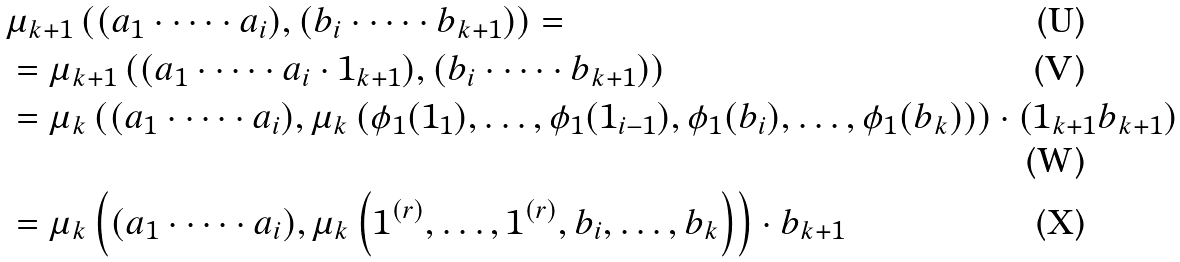<formula> <loc_0><loc_0><loc_500><loc_500>& \mu _ { k + 1 } \left ( ( a _ { 1 } \cdot \dots \cdot a _ { i } ) , ( b _ { i } \cdot \dots \cdot b _ { k + 1 } ) \right ) = \\ & = \mu _ { k + 1 } \left ( ( a _ { 1 } \cdot \dots \cdot a _ { i } \cdot 1 _ { k + 1 } ) , ( b _ { i } \cdot \dots \cdot b _ { k + 1 } ) \right ) \\ & = \mu _ { k } \left ( ( a _ { 1 } \cdot \dots \cdot a _ { i } ) , \mu _ { k } \left ( \phi _ { 1 } ( 1 _ { 1 } ) , \dots , \phi _ { 1 } ( 1 _ { i - 1 } ) , \phi _ { 1 } ( b _ { i } ) , \dots , \phi _ { 1 } ( b _ { k } ) \right ) \right ) \cdot ( 1 _ { k + 1 } b _ { k + 1 } ) \\ & = \mu _ { k } \left ( ( a _ { 1 } \cdot \dots \cdot a _ { i } ) , \mu _ { k } \left ( 1 ^ { ( r ) } , \dots , 1 ^ { ( r ) } , b _ { i } , \dots , b _ { k } \right ) \right ) \cdot b _ { k + 1 }</formula> 